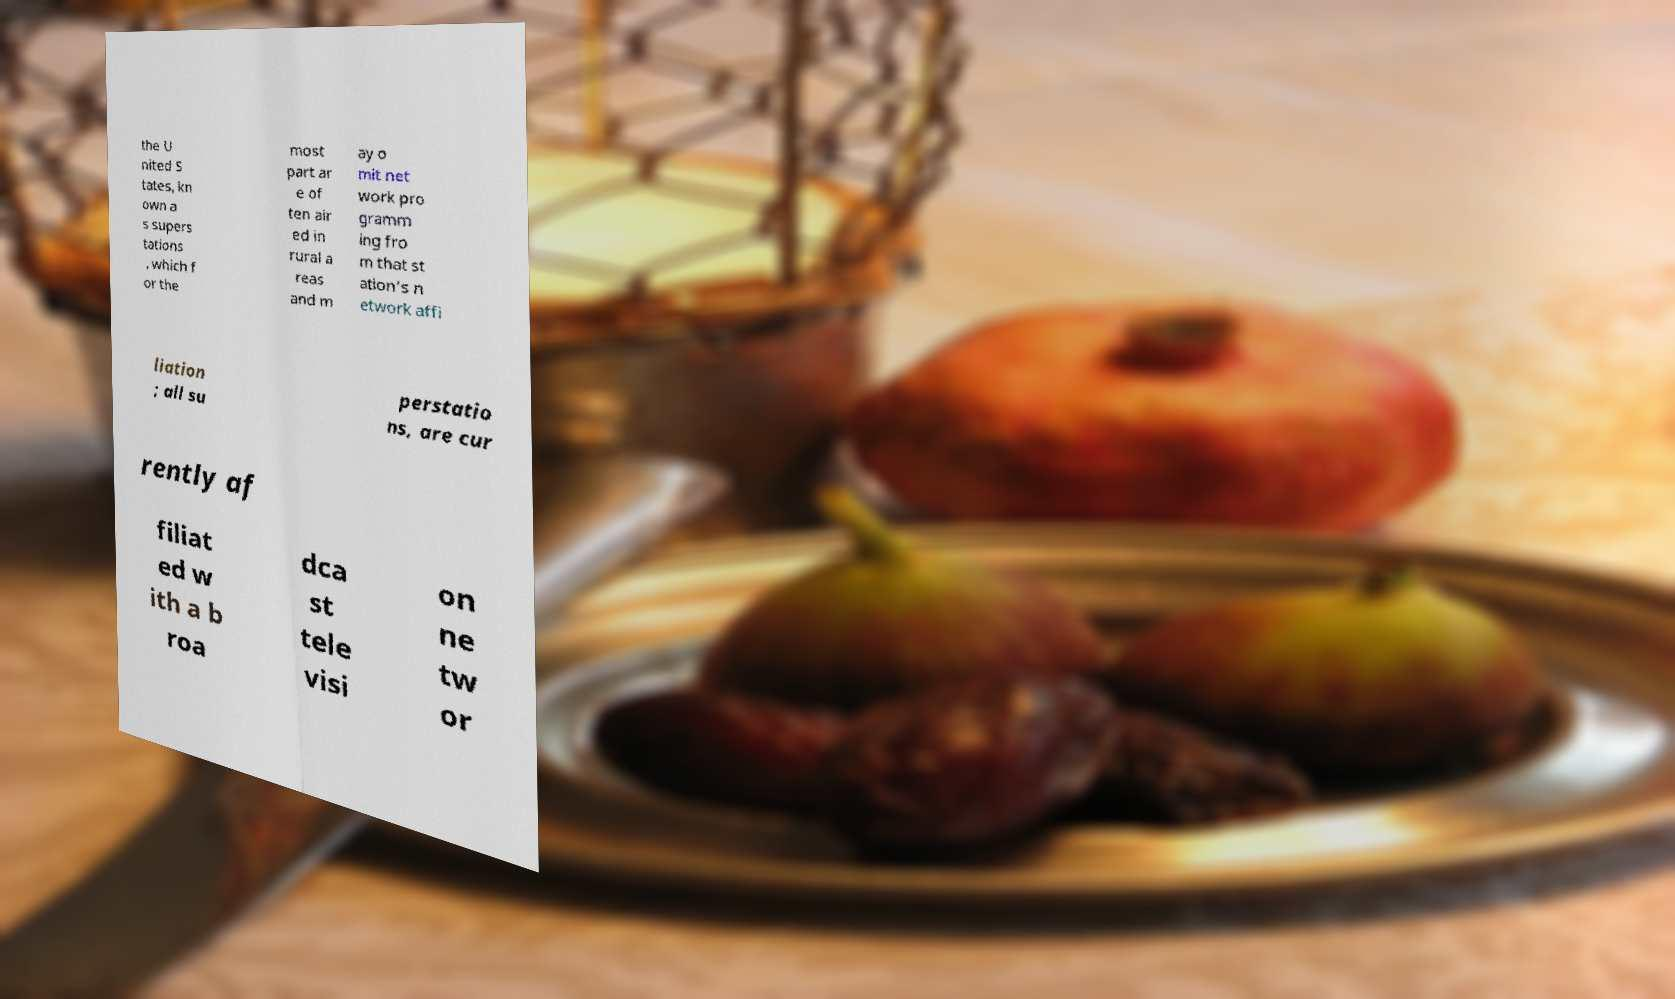Could you assist in decoding the text presented in this image and type it out clearly? the U nited S tates, kn own a s supers tations , which f or the most part ar e of ten air ed in rural a reas and m ay o mit net work pro gramm ing fro m that st ation's n etwork affi liation ; all su perstatio ns, are cur rently af filiat ed w ith a b roa dca st tele visi on ne tw or 